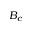Convert formula to latex. <formula><loc_0><loc_0><loc_500><loc_500>B _ { c }</formula> 